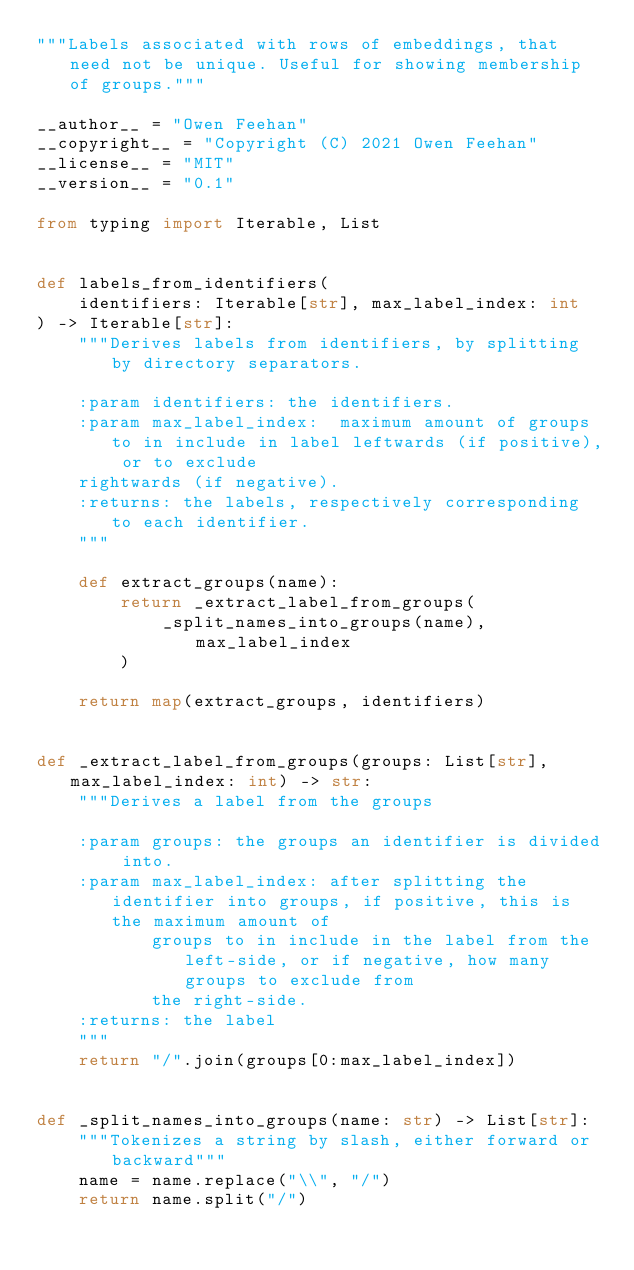<code> <loc_0><loc_0><loc_500><loc_500><_Python_>"""Labels associated with rows of embeddings, that need not be unique. Useful for showing membership of groups."""

__author__ = "Owen Feehan"
__copyright__ = "Copyright (C) 2021 Owen Feehan"
__license__ = "MIT"
__version__ = "0.1"

from typing import Iterable, List


def labels_from_identifiers(
    identifiers: Iterable[str], max_label_index: int
) -> Iterable[str]:
    """Derives labels from identifiers, by splitting by directory separators.

    :param identifiers: the identifiers.
    :param max_label_index:  maximum amount of groups to in include in label leftwards (if positive), or to exclude
    rightwards (if negative).
    :returns: the labels, respectively corresponding to each identifier.
    """

    def extract_groups(name):
        return _extract_label_from_groups(
            _split_names_into_groups(name), max_label_index
        )

    return map(extract_groups, identifiers)


def _extract_label_from_groups(groups: List[str], max_label_index: int) -> str:
    """Derives a label from the groups

    :param groups: the groups an identifier is divided into.
    :param max_label_index: after splitting the identifier into groups, if positive, this is the maximum amount of
           groups to in include in the label from the left-side, or if negative, how many groups to exclude from
           the right-side.
    :returns: the label
    """
    return "/".join(groups[0:max_label_index])


def _split_names_into_groups(name: str) -> List[str]:
    """Tokenizes a string by slash, either forward or backward"""
    name = name.replace("\\", "/")
    return name.split("/")
</code> 